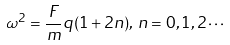Convert formula to latex. <formula><loc_0><loc_0><loc_500><loc_500>\omega ^ { 2 } = \frac { F } { m } q ( 1 + 2 n ) , \, n = 0 , 1 , 2 \cdots</formula> 